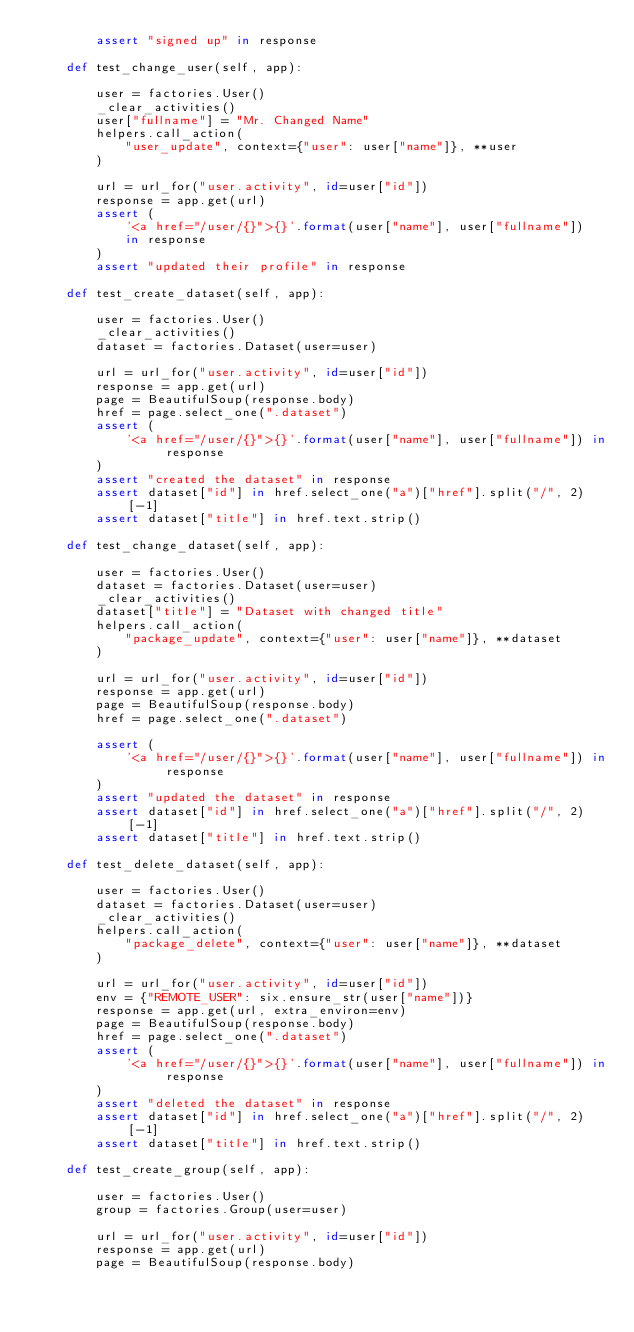Convert code to text. <code><loc_0><loc_0><loc_500><loc_500><_Python_>        assert "signed up" in response

    def test_change_user(self, app):

        user = factories.User()
        _clear_activities()
        user["fullname"] = "Mr. Changed Name"
        helpers.call_action(
            "user_update", context={"user": user["name"]}, **user
        )

        url = url_for("user.activity", id=user["id"])
        response = app.get(url)
        assert (
            '<a href="/user/{}">{}'.format(user["name"], user["fullname"])
            in response
        )
        assert "updated their profile" in response

    def test_create_dataset(self, app):

        user = factories.User()
        _clear_activities()
        dataset = factories.Dataset(user=user)

        url = url_for("user.activity", id=user["id"])
        response = app.get(url)
        page = BeautifulSoup(response.body)
        href = page.select_one(".dataset")
        assert (
            '<a href="/user/{}">{}'.format(user["name"], user["fullname"]) in response
        )
        assert "created the dataset" in response
        assert dataset["id"] in href.select_one("a")["href"].split("/", 2)[-1]
        assert dataset["title"] in href.text.strip()

    def test_change_dataset(self, app):

        user = factories.User()
        dataset = factories.Dataset(user=user)
        _clear_activities()
        dataset["title"] = "Dataset with changed title"
        helpers.call_action(
            "package_update", context={"user": user["name"]}, **dataset
        )

        url = url_for("user.activity", id=user["id"])
        response = app.get(url)
        page = BeautifulSoup(response.body)
        href = page.select_one(".dataset")

        assert (
            '<a href="/user/{}">{}'.format(user["name"], user["fullname"]) in response
        )
        assert "updated the dataset" in response
        assert dataset["id"] in href.select_one("a")["href"].split("/", 2)[-1]
        assert dataset["title"] in href.text.strip()

    def test_delete_dataset(self, app):

        user = factories.User()
        dataset = factories.Dataset(user=user)
        _clear_activities()
        helpers.call_action(
            "package_delete", context={"user": user["name"]}, **dataset
        )

        url = url_for("user.activity", id=user["id"])
        env = {"REMOTE_USER": six.ensure_str(user["name"])}
        response = app.get(url, extra_environ=env)
        page = BeautifulSoup(response.body)
        href = page.select_one(".dataset")
        assert (
            '<a href="/user/{}">{}'.format(user["name"], user["fullname"]) in response
        )
        assert "deleted the dataset" in response
        assert dataset["id"] in href.select_one("a")["href"].split("/", 2)[-1]
        assert dataset["title"] in href.text.strip()

    def test_create_group(self, app):

        user = factories.User()
        group = factories.Group(user=user)

        url = url_for("user.activity", id=user["id"])
        response = app.get(url)
        page = BeautifulSoup(response.body)</code> 